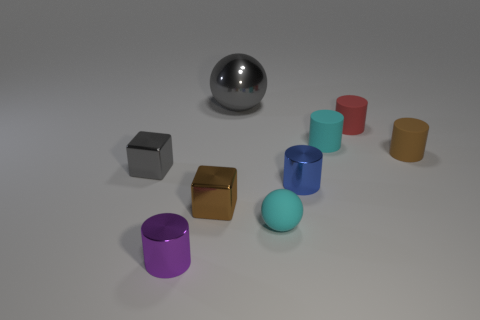How many other objects are the same color as the large shiny thing?
Provide a short and direct response. 1. Are there more small cyan balls that are behind the purple object than yellow rubber balls?
Make the answer very short. Yes. Are the tiny red cylinder and the brown cylinder made of the same material?
Ensure brevity in your answer.  Yes. What number of objects are small objects that are behind the purple cylinder or tiny red matte cylinders?
Make the answer very short. 7. How many other objects are there of the same size as the gray cube?
Offer a very short reply. 7. Is the number of small red cylinders behind the tiny cyan matte cylinder the same as the number of gray metallic spheres right of the small cyan sphere?
Keep it short and to the point. No. There is another tiny metal object that is the same shape as the small purple thing; what is its color?
Offer a terse response. Blue. Do the tiny thing left of the small purple shiny cylinder and the big metal object have the same color?
Offer a very short reply. Yes. The brown thing that is the same shape as the small gray object is what size?
Your response must be concise. Small. How many small purple objects have the same material as the small cyan cylinder?
Your answer should be very brief. 0. 